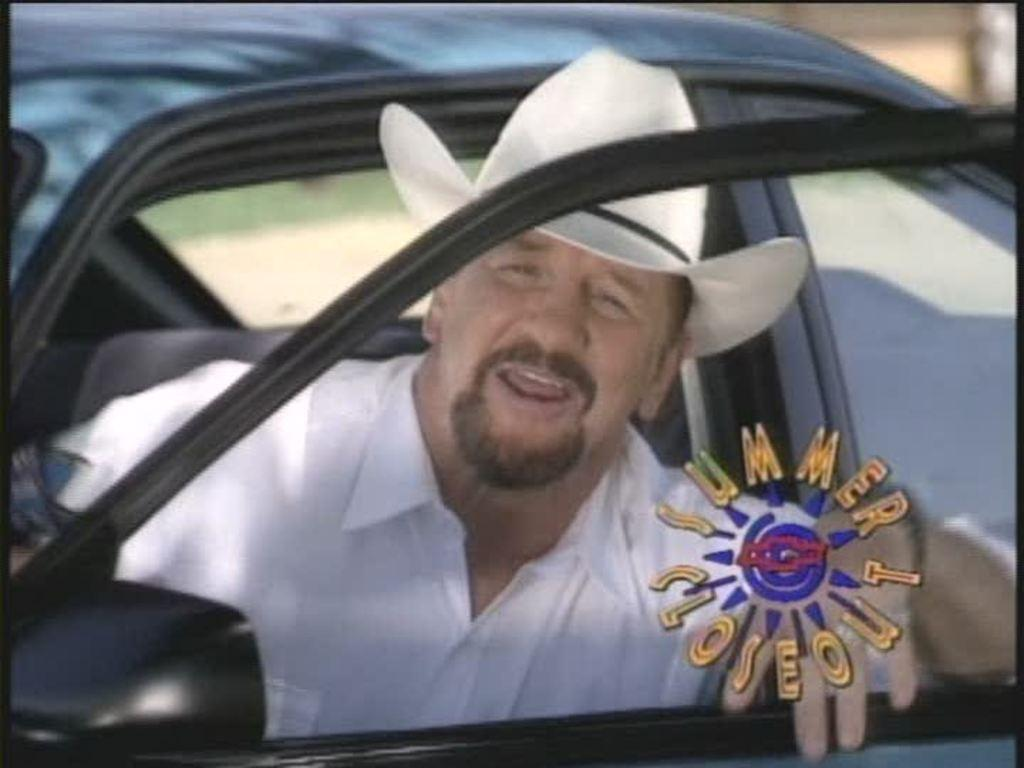Who is present in the image? There is a man in the image. What is the man doing in the image? The man is sitting in a car. What is the position of the car door in the image? The car door is open. What is the man looking at in the image? The man is looking through the car window. What is the name of the giant standing next to the car in the image? There are no giants present in the image; it only features a man sitting in a car with an open door. 